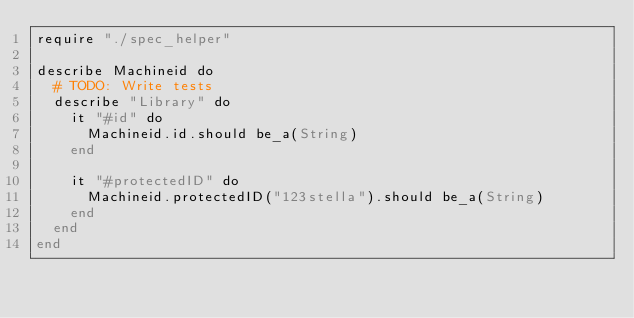Convert code to text. <code><loc_0><loc_0><loc_500><loc_500><_Crystal_>require "./spec_helper"

describe Machineid do
  # TODO: Write tests
  describe "Library" do
    it "#id" do
      Machineid.id.should be_a(String)
    end

    it "#protectedID" do
      Machineid.protectedID("123stella").should be_a(String)
    end
  end
end
</code> 